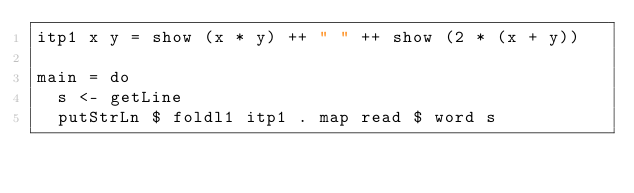<code> <loc_0><loc_0><loc_500><loc_500><_Haskell_>itp1 x y = show (x * y) ++ " " ++ show (2 * (x + y))

main = do
  s <- getLine
  putStrLn $ foldl1 itp1 . map read $ word s</code> 